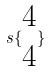<formula> <loc_0><loc_0><loc_500><loc_500>s \{ \begin{matrix} 4 \\ 4 \end{matrix} \}</formula> 